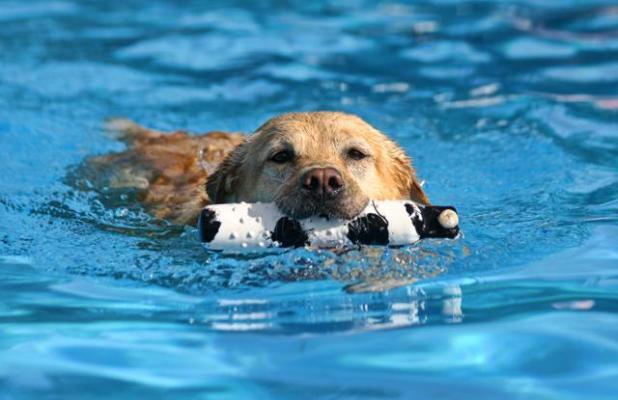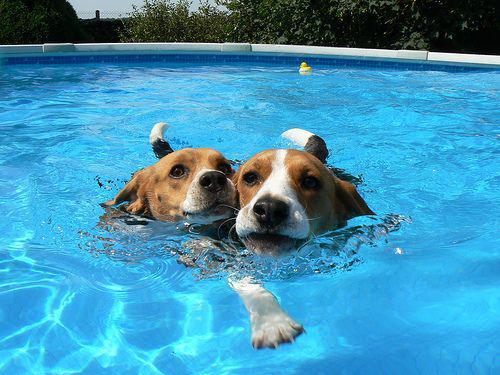The first image is the image on the left, the second image is the image on the right. Examine the images to the left and right. Is the description "A person is visible in a pool that also has a dog in it." accurate? Answer yes or no. No. The first image is the image on the left, the second image is the image on the right. Considering the images on both sides, is "There are two dogs in total." valid? Answer yes or no. No. 